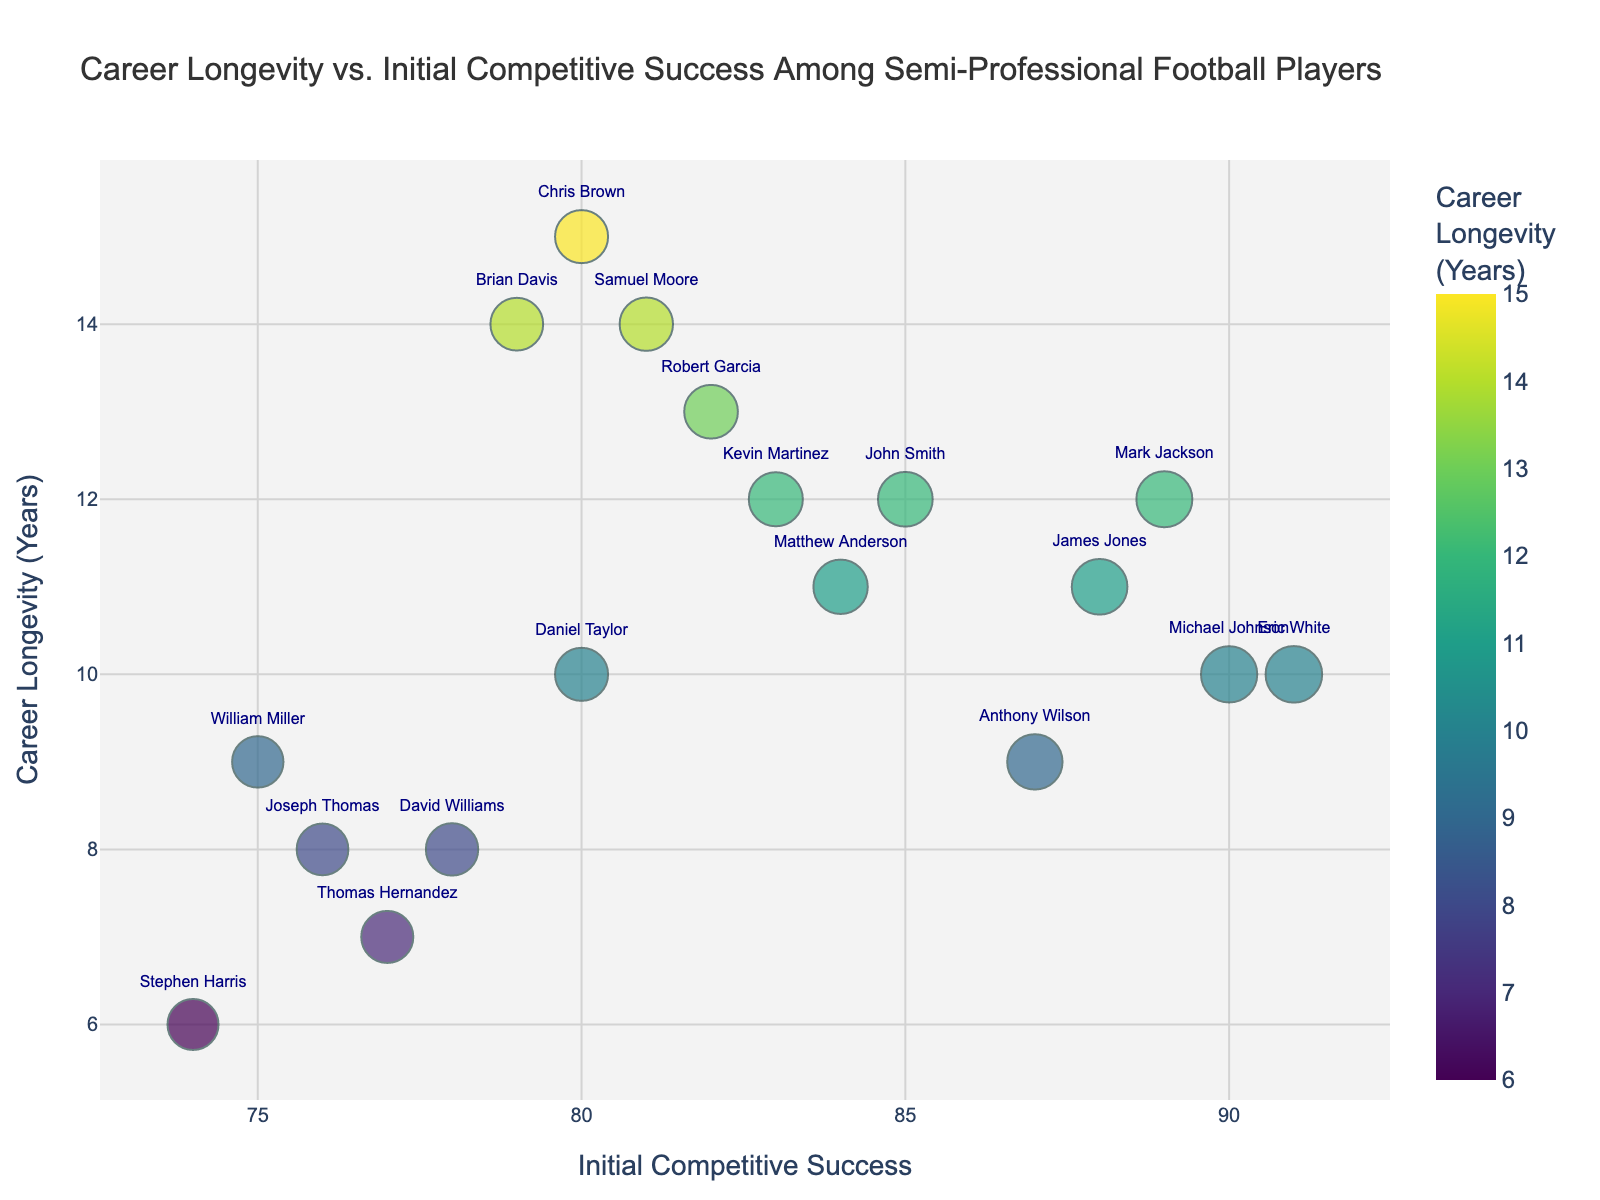How many players are represented in the scatter plot? Each data point represents a player, and each player has unique data for Initial Competitive Success and Career Longevity. By counting the data points in the scatter plot, we determine the number of players.
Answer: 18 Which player has the highest Initial Competitive Success rating? To find the player with the highest rating, we look for the data point positioned furthest to the right on the x-axis. This player's rating is 91.
Answer: Eric White What colors are used to represent Career Longevity in the scatter plot? The scatter plot uses a continuous color scale to represent Career Longevity, moving through different shades. This color scheme helps distinguish between varying lengths of Career Longevity.
Answer: Various shades from the Viridis palette Who has the shortest career longevity? We search for the data point lowest on the y-axis, indicating the shortest Career Longevity. This player's Career Longevity is 6 years.
Answer: Stephen Harris What is the relationship between Initial Competitive Success and Career Longevity according to the scatter plot? By examining the trend of data points, we can infer the overall relationship. If the points are widespread with no clear trend, there's no significant correlation, but observing clustering might suggest trends.
Answer: No clear correlation Between players Samuel Moore and John Smith, who has the longer Career Longevity? Identify the positions of Samuel Moore and John Smith on the y-axis and compare to determine who is higher, thus having a longer Career Longevity.
Answer: Samuel Moore Which player has both a high Initial Competitive Success rating and a long Career Longevity? Look for the point that is positioned high on both the x and y axes, indicating both high success and long career.
Answer: Chris Brown What is the range of Career Longevity among the players? Identify the minimum and maximum values on the y-axis. The range is the difference between these values.
Answer: 6 to 15 years How many players have a Career Longevity of 10 years? Identify the data points positioned precisely at y = 10. Count these points to determine the number of players with this Career Longevity.
Answer: 4 Who has a longer career longevity, player Robert Garcia or player Matthew Anderson? Compare the y-axis values where Robert Garcia and Matthew Anderson are located. The player higher on the y-axis has a longer Career Longevity.
Answer: Robert Garcia 